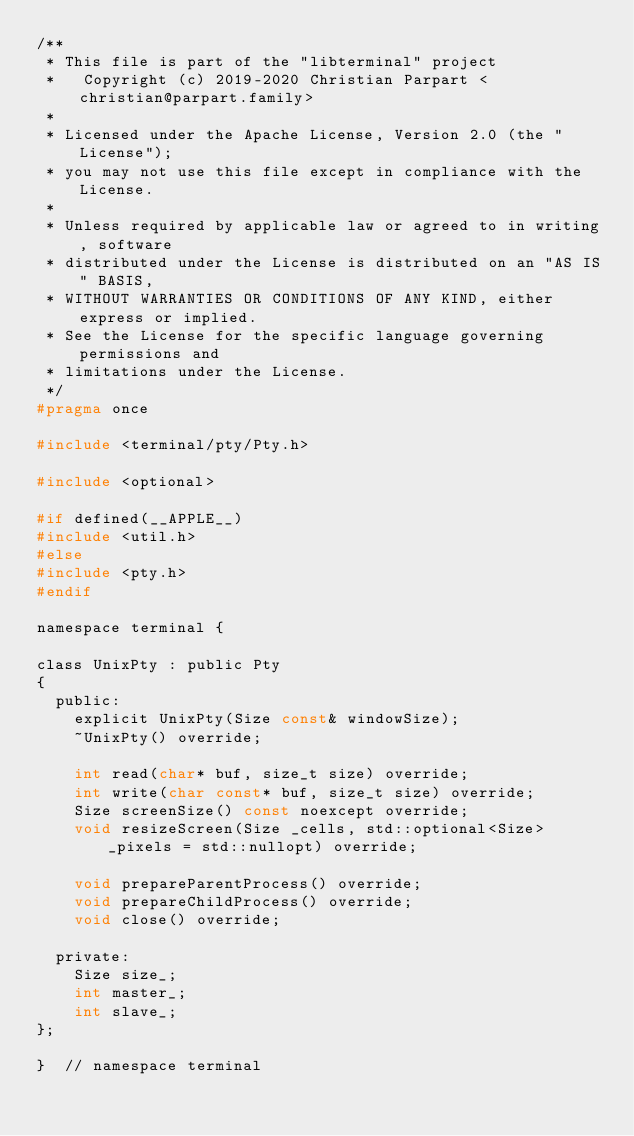Convert code to text. <code><loc_0><loc_0><loc_500><loc_500><_C_>/**
 * This file is part of the "libterminal" project
 *   Copyright (c) 2019-2020 Christian Parpart <christian@parpart.family>
 *
 * Licensed under the Apache License, Version 2.0 (the "License");
 * you may not use this file except in compliance with the License.
 *
 * Unless required by applicable law or agreed to in writing, software
 * distributed under the License is distributed on an "AS IS" BASIS,
 * WITHOUT WARRANTIES OR CONDITIONS OF ANY KIND, either express or implied.
 * See the License for the specific language governing permissions and
 * limitations under the License.
 */
#pragma once

#include <terminal/pty/Pty.h>

#include <optional>

#if defined(__APPLE__)
#include <util.h>
#else
#include <pty.h>
#endif

namespace terminal {

class UnixPty : public Pty
{
  public:
    explicit UnixPty(Size const& windowSize);
    ~UnixPty() override;

    int read(char* buf, size_t size) override;
    int write(char const* buf, size_t size) override;
    Size screenSize() const noexcept override;
    void resizeScreen(Size _cells, std::optional<Size> _pixels = std::nullopt) override;

    void prepareParentProcess() override;
    void prepareChildProcess() override;
    void close() override;

  private:
    Size size_;
    int master_;
    int slave_;
};

}  // namespace terminal
</code> 